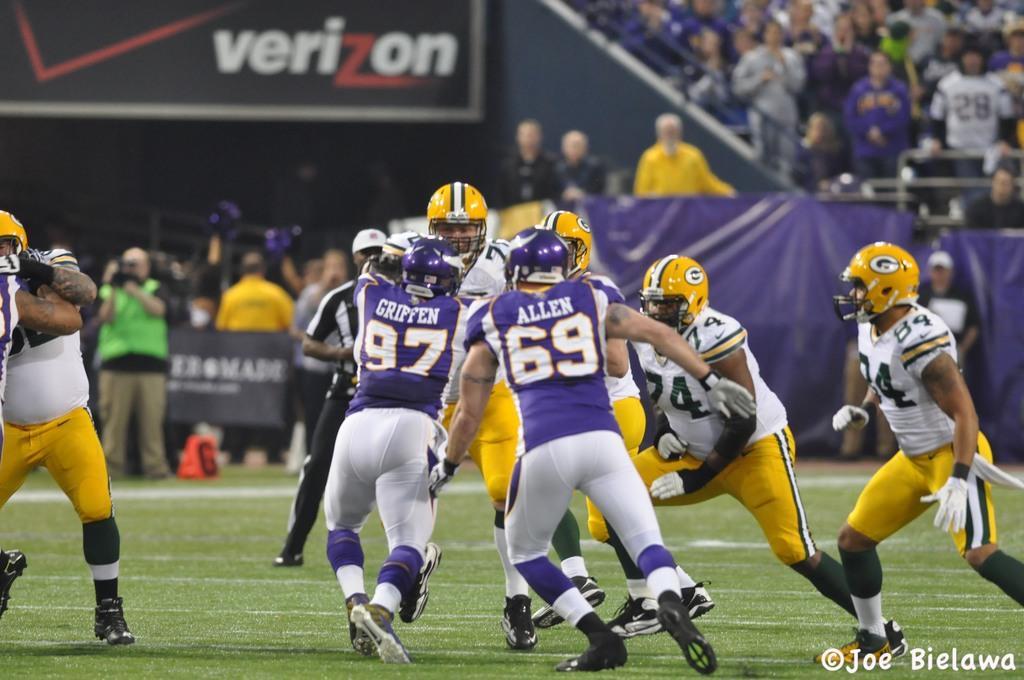Please provide a concise description of this image. In the image there are few people in yellow jersey and few people in purple jersey running on the grassland, this seems to be rugby, in the back there are many people sitting on chairs and looking at the game. 